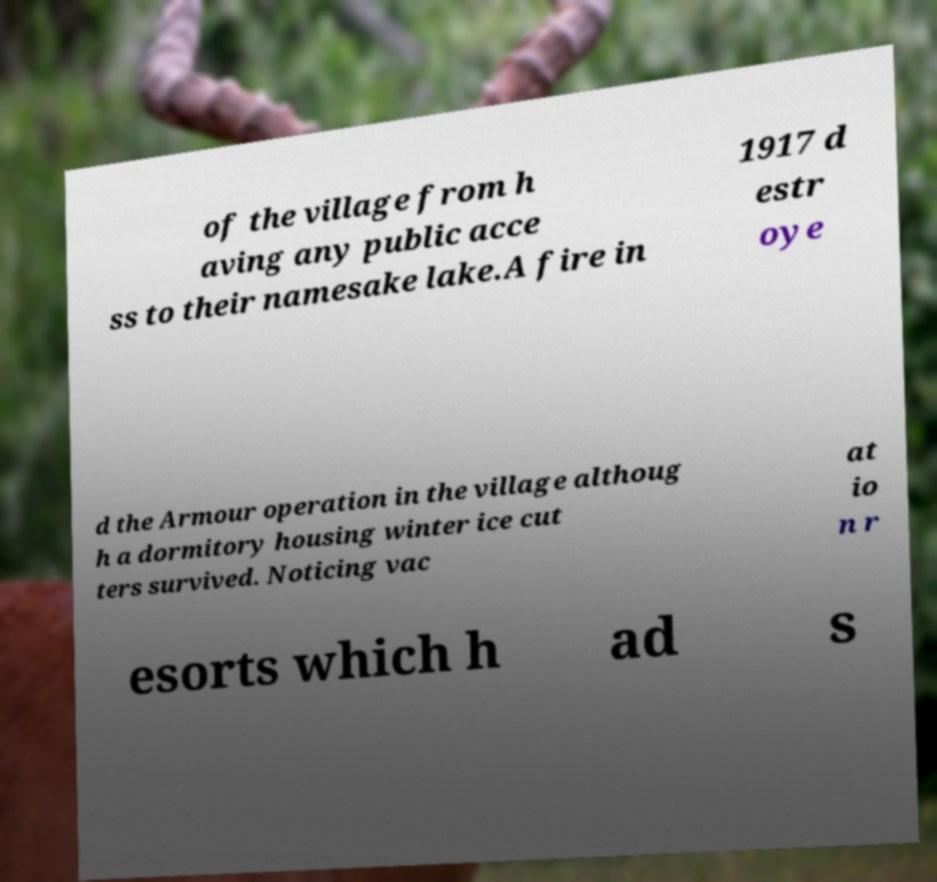Could you extract and type out the text from this image? of the village from h aving any public acce ss to their namesake lake.A fire in 1917 d estr oye d the Armour operation in the village althoug h a dormitory housing winter ice cut ters survived. Noticing vac at io n r esorts which h ad s 